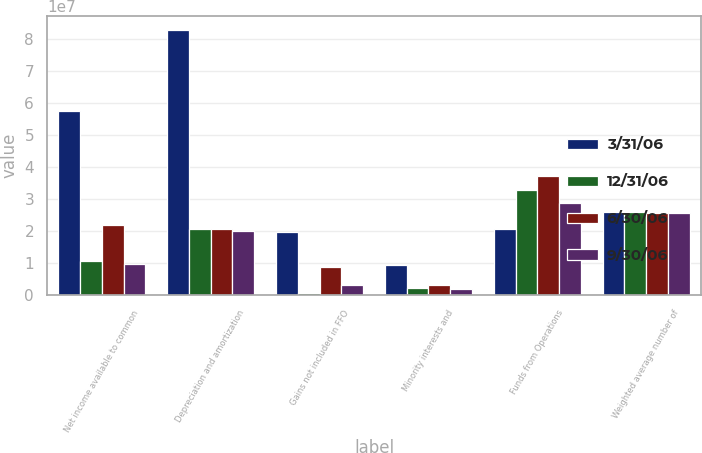Convert chart to OTSL. <chart><loc_0><loc_0><loc_500><loc_500><stacked_bar_chart><ecel><fcel>Net income available to common<fcel>Depreciation and amortization<fcel>Gains not included in FFO<fcel>Minority interests and<fcel>Funds from Operations<fcel>Weighted average number of<nl><fcel>3/31/06<fcel>5.7603e+07<fcel>8.3034e+07<fcel>1.9666e+07<fcel>9.547e+06<fcel>2.0666e+07<fcel>2.60298e+07<nl><fcel>12/31/06<fcel>1.0686e+07<fcel>2.0666e+07<fcel>714000<fcel>2.217e+06<fcel>3.2855e+07<fcel>2.61439e+07<nl><fcel>6/30/06<fcel>2.2023e+07<fcel>2.0675e+07<fcel>8.8e+06<fcel>3.254e+06<fcel>3.7152e+07<fcel>2.56972e+07<nl><fcel>9/30/06<fcel>9.834e+06<fcel>2.0091e+07<fcel>3.062e+06<fcel>2.053e+06<fcel>2.8916e+07<fcel>2.55726e+07<nl></chart> 